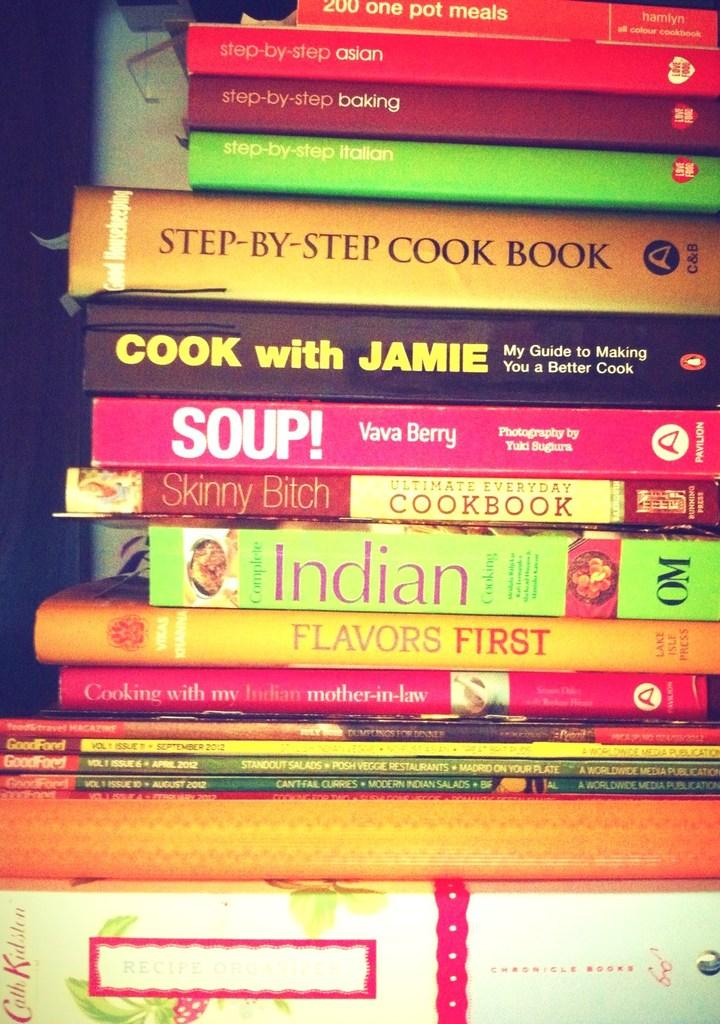Provide a one-sentence caption for the provided image. A stack of cookbooks from various cuisines ad authors. 